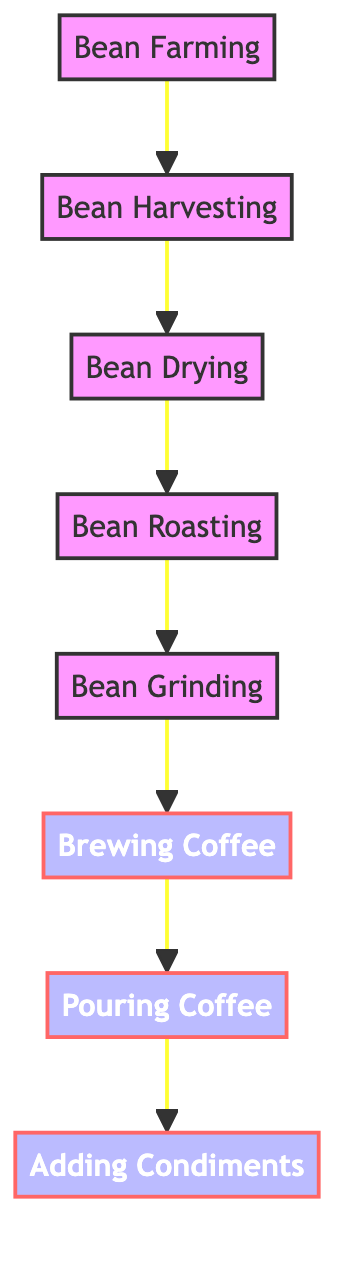What is the starting point in the coffee-making process? The starting point in the coffee-making process is "Bean Farming," which is the first node in the directed graph.
Answer: Bean Farming How many total nodes are present in the diagram? Counting all the unique steps represented in the diagram, there are eight nodes: Bean Farming, Bean Harvesting, Bean Drying, Bean Roasting, Bean Grinding, Brewing Coffee, Pouring Coffee, and Adding Condiments.
Answer: 8 What is the final step before adding condiments? The final step before adding condiments is "Pouring Coffee," which is immediately connected to the "Adding Condiments" node in the diagram.
Answer: Pouring Coffee What step comes directly after bean drying? The step that comes directly after "Bean Drying" is "Bean Roasting," as indicated by the directional edge leading from the former to the latter in the graph.
Answer: Bean Roasting How many edges are used to connect all the steps in the process? By counting the connections (edges) between the nodes, there are seven edges displayed in the diagram, showing the flow from the starting to the final step.
Answer: 7 Which process step has direct connections to the steps before and after it? The "Brewing Coffee" step has direct connections to both "Bean Grinding" before it and "Pouring Coffee" after it, making it a central part of the workflow.
Answer: Brewing Coffee What action follows brewing coffee in this process? The action that follows "Brewing Coffee" is "Pouring Coffee," which directly follows in the sequence shown in the diagram.
Answer: Pouring Coffee What are the condiments added after the coffee is poured? The condiments added after the coffee is poured are sugar and milk, although they are not specified in the diagram; "Adding Condiments" suggests these common additions.
Answer: sugar, milk 